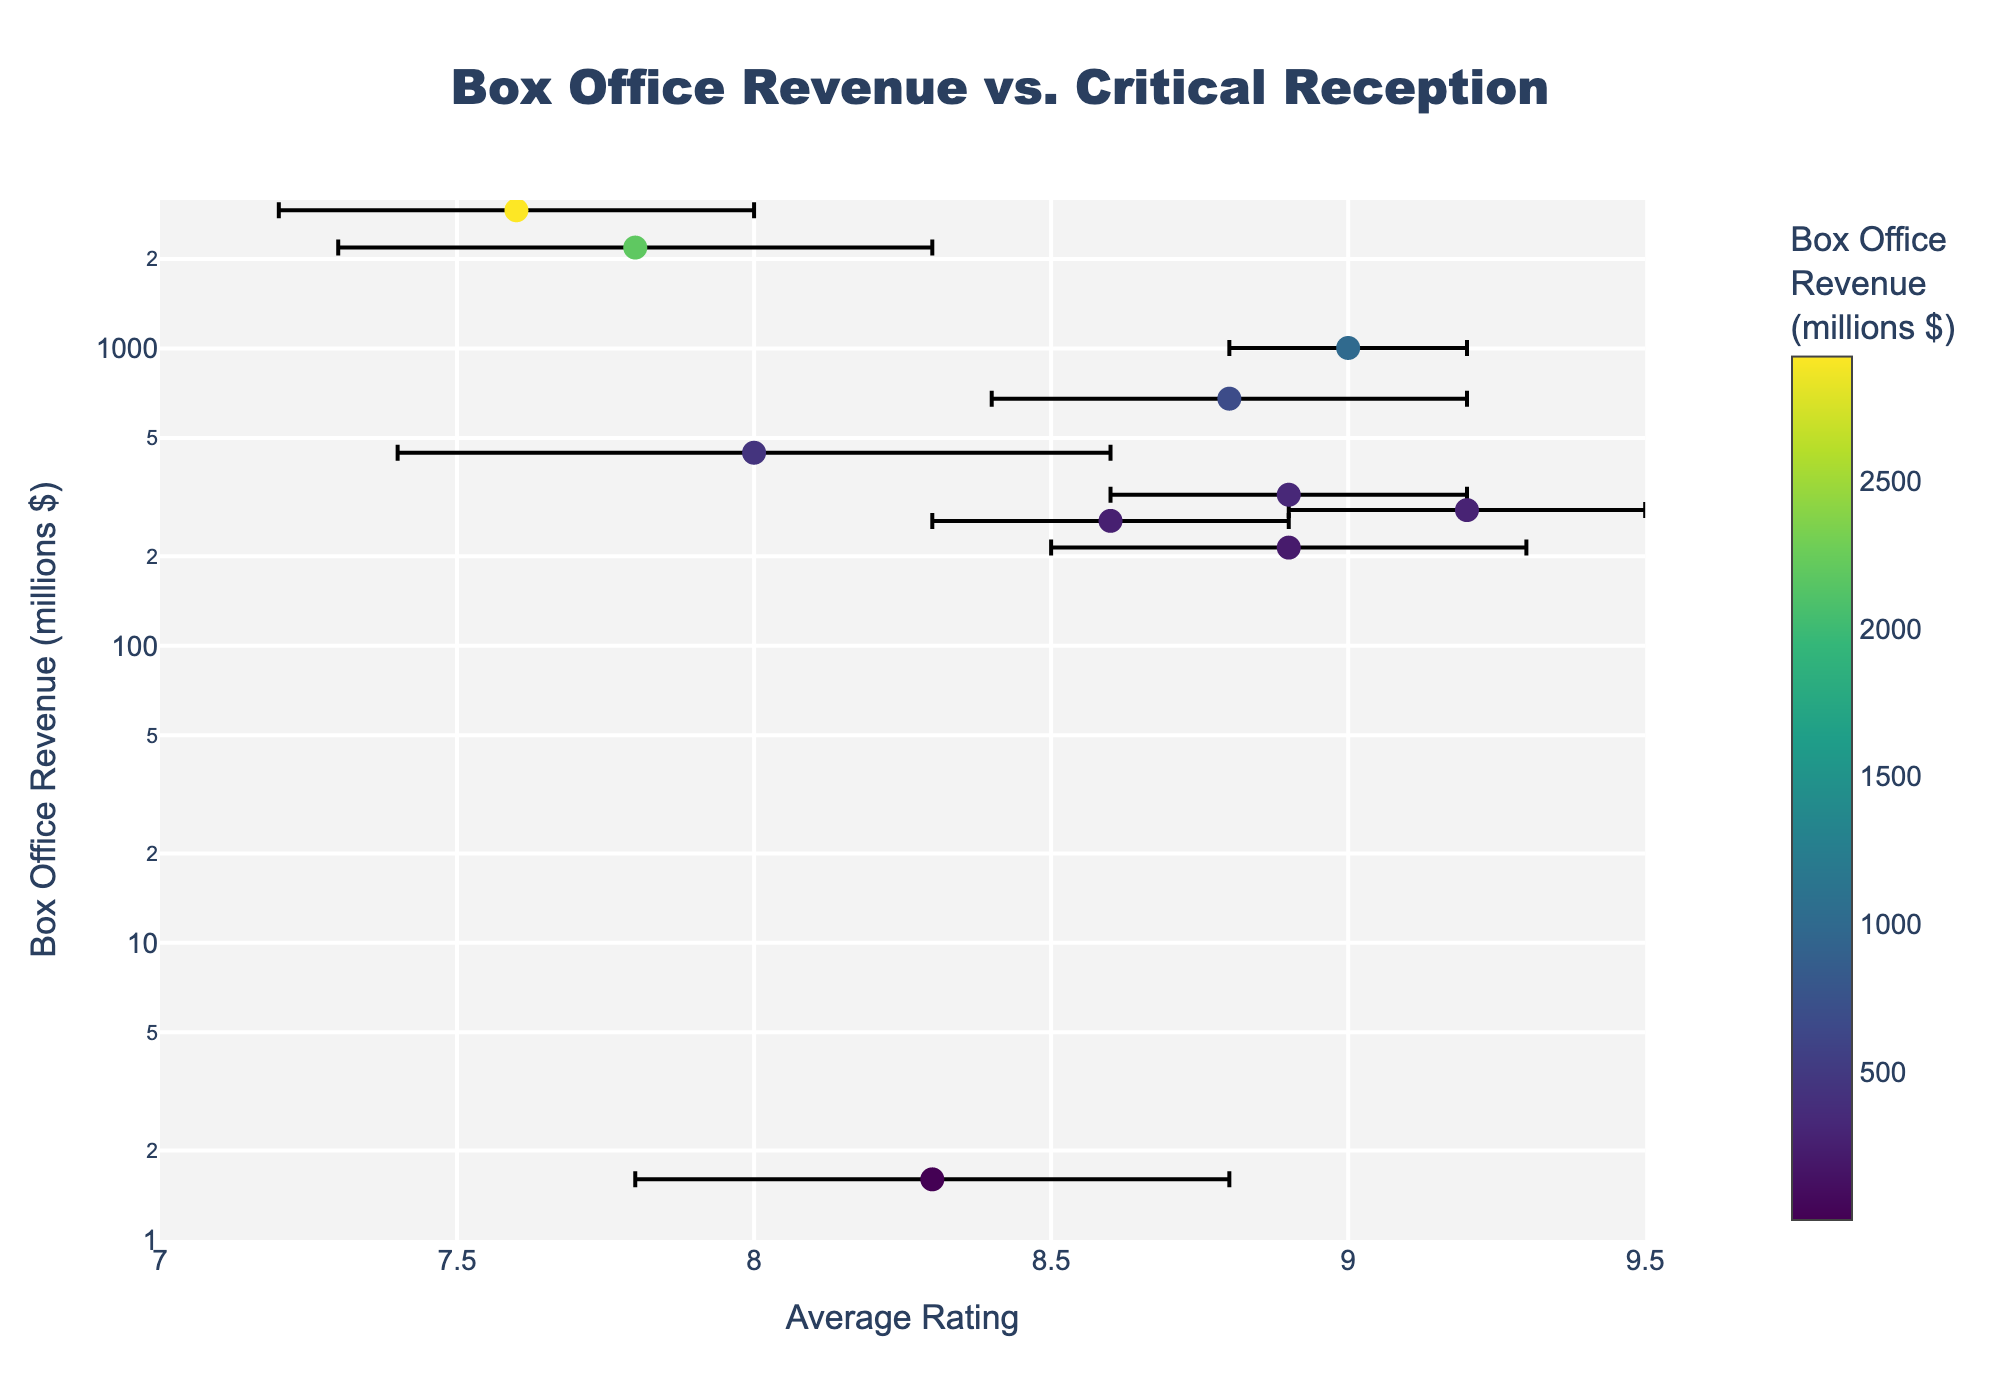What's the title of the figure? The title is displayed prominently at the top of the figure and reads, "Box Office Revenue vs. Critical Reception".
Answer: Box Office Revenue vs. Critical Reception What is the x-axis representing? The x-axis shows "Average Rating" given to the films.
Answer: Average Rating What is the y-axis measuring? The y-axis measures "Box Office Revenue" in millions of dollars.
Answer: Box Office Revenue (millions $) How many data points are there in the figure? By observing the number of marker points in the scatter plot, there are 10 data points, each corresponding to a film.
Answer: 10 Which film has the highest box office revenue? The film with the highest box office revenue is marked by the top-most point in the plot, which is "Avatar" at approximately 2920 million dollars.
Answer: Avatar Which film has the highest average rating? The film with the highest average rating is "The Godfather" with an average rating of 9.2, indicated by its position on the far right of the plot.
Answer: The Godfather What is the standard deviation of ratings for "Titanic"? By hovering over or observing the error bars on the plot, "Titanic" shows a standard deviation of 0.5 in the ratings.
Answer: 0.5 Which film, "Pulp Fiction" or "Forrest Gump", has a higher box office revenue? Comparing the y-axis values for both films, "Forrest Gump" has a higher box office revenue at 678.2 million dollars compared to "Pulp Fiction" at 213.9 million dollars.
Answer: Forrest Gump Is there any film with an average rating below 8? By observing the x-axis range and data points, the films "La La Land", "Titanic", and "Avatar" have average ratings below 8.
Answer: Yes What is the range of the y-axis on the plot? The y-axis range is logarithmic, spanning from approximately 1 million dollars to over 3000 million dollars.
Answer: 1 million to 3000 million 